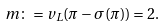<formula> <loc_0><loc_0><loc_500><loc_500>m \colon = v _ { L } ( \pi - \sigma ( \pi ) ) = 2 .</formula> 